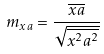Convert formula to latex. <formula><loc_0><loc_0><loc_500><loc_500>m _ { x a } = \frac { \overline { x a } } { \sqrt { \overline { x ^ { 2 } } \overline { a ^ { 2 } } } }</formula> 